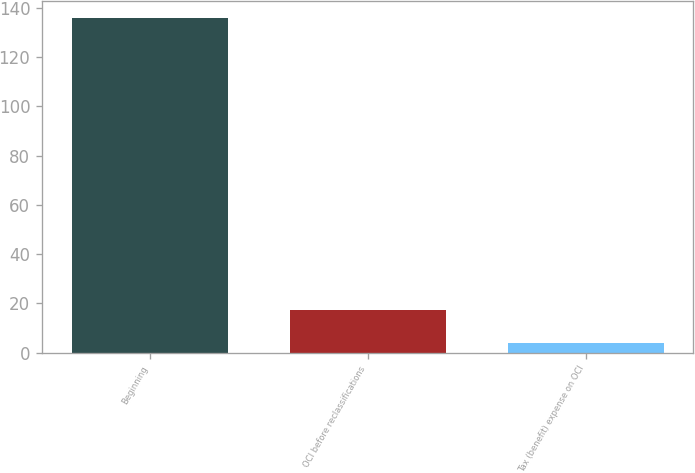Convert chart to OTSL. <chart><loc_0><loc_0><loc_500><loc_500><bar_chart><fcel>Beginning<fcel>OCI before reclassifications<fcel>Tax (benefit) expense on OCI<nl><fcel>136<fcel>17.2<fcel>4<nl></chart> 